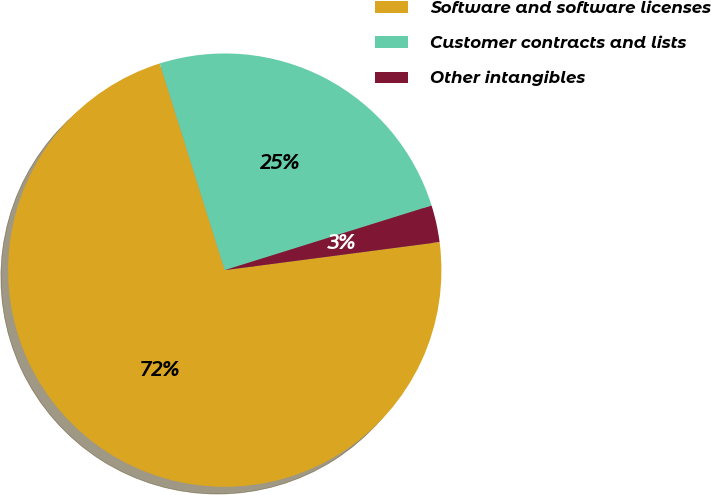Convert chart. <chart><loc_0><loc_0><loc_500><loc_500><pie_chart><fcel>Software and software licenses<fcel>Customer contracts and lists<fcel>Other intangibles<nl><fcel>72.22%<fcel>25.03%<fcel>2.75%<nl></chart> 